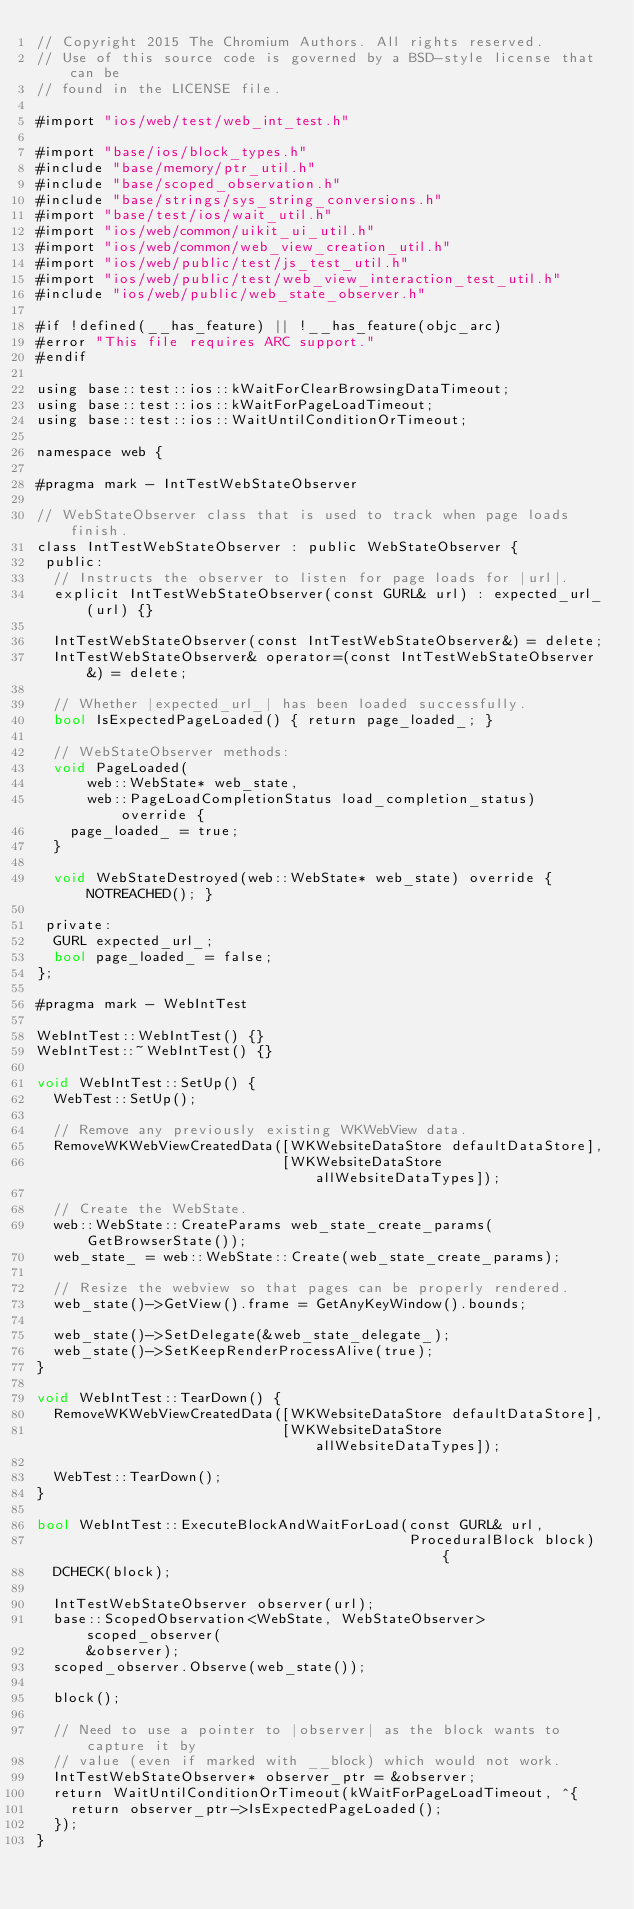<code> <loc_0><loc_0><loc_500><loc_500><_ObjectiveC_>// Copyright 2015 The Chromium Authors. All rights reserved.
// Use of this source code is governed by a BSD-style license that can be
// found in the LICENSE file.

#import "ios/web/test/web_int_test.h"

#import "base/ios/block_types.h"
#include "base/memory/ptr_util.h"
#include "base/scoped_observation.h"
#include "base/strings/sys_string_conversions.h"
#import "base/test/ios/wait_util.h"
#import "ios/web/common/uikit_ui_util.h"
#import "ios/web/common/web_view_creation_util.h"
#import "ios/web/public/test/js_test_util.h"
#import "ios/web/public/test/web_view_interaction_test_util.h"
#include "ios/web/public/web_state_observer.h"

#if !defined(__has_feature) || !__has_feature(objc_arc)
#error "This file requires ARC support."
#endif

using base::test::ios::kWaitForClearBrowsingDataTimeout;
using base::test::ios::kWaitForPageLoadTimeout;
using base::test::ios::WaitUntilConditionOrTimeout;

namespace web {

#pragma mark - IntTestWebStateObserver

// WebStateObserver class that is used to track when page loads finish.
class IntTestWebStateObserver : public WebStateObserver {
 public:
  // Instructs the observer to listen for page loads for |url|.
  explicit IntTestWebStateObserver(const GURL& url) : expected_url_(url) {}

  IntTestWebStateObserver(const IntTestWebStateObserver&) = delete;
  IntTestWebStateObserver& operator=(const IntTestWebStateObserver&) = delete;

  // Whether |expected_url_| has been loaded successfully.
  bool IsExpectedPageLoaded() { return page_loaded_; }

  // WebStateObserver methods:
  void PageLoaded(
      web::WebState* web_state,
      web::PageLoadCompletionStatus load_completion_status) override {
    page_loaded_ = true;
  }

  void WebStateDestroyed(web::WebState* web_state) override { NOTREACHED(); }

 private:
  GURL expected_url_;
  bool page_loaded_ = false;
};

#pragma mark - WebIntTest

WebIntTest::WebIntTest() {}
WebIntTest::~WebIntTest() {}

void WebIntTest::SetUp() {
  WebTest::SetUp();

  // Remove any previously existing WKWebView data.
  RemoveWKWebViewCreatedData([WKWebsiteDataStore defaultDataStore],
                             [WKWebsiteDataStore allWebsiteDataTypes]);

  // Create the WebState.
  web::WebState::CreateParams web_state_create_params(GetBrowserState());
  web_state_ = web::WebState::Create(web_state_create_params);

  // Resize the webview so that pages can be properly rendered.
  web_state()->GetView().frame = GetAnyKeyWindow().bounds;

  web_state()->SetDelegate(&web_state_delegate_);
  web_state()->SetKeepRenderProcessAlive(true);
}

void WebIntTest::TearDown() {
  RemoveWKWebViewCreatedData([WKWebsiteDataStore defaultDataStore],
                             [WKWebsiteDataStore allWebsiteDataTypes]);

  WebTest::TearDown();
}

bool WebIntTest::ExecuteBlockAndWaitForLoad(const GURL& url,
                                            ProceduralBlock block) {
  DCHECK(block);

  IntTestWebStateObserver observer(url);
  base::ScopedObservation<WebState, WebStateObserver> scoped_observer(
      &observer);
  scoped_observer.Observe(web_state());

  block();

  // Need to use a pointer to |observer| as the block wants to capture it by
  // value (even if marked with __block) which would not work.
  IntTestWebStateObserver* observer_ptr = &observer;
  return WaitUntilConditionOrTimeout(kWaitForPageLoadTimeout, ^{
    return observer_ptr->IsExpectedPageLoaded();
  });
}
</code> 